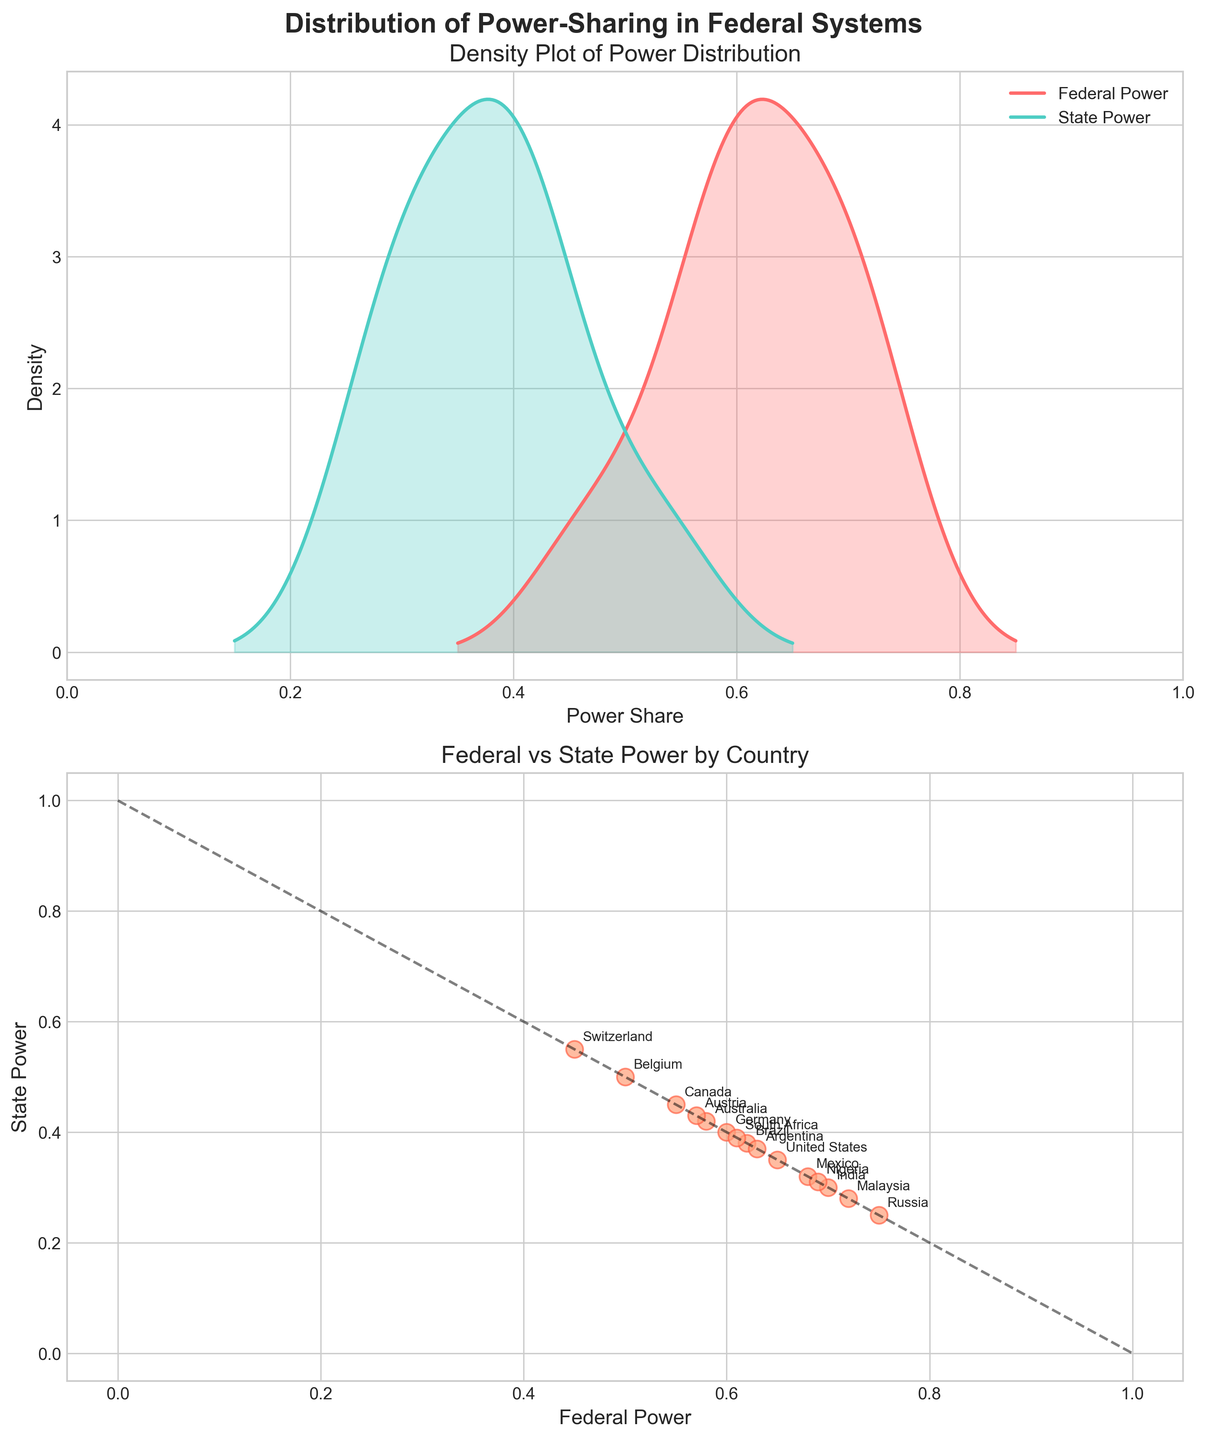What is the title of the figure? The title is written at the top of the figure in large, bold font. It reads "Distribution of Power-Sharing in Federal Systems".
Answer: Distribution of Power-Sharing in Federal Systems Which country has the highest Federal Power share? By looking at the scatter plot, the country with the highest Federal Power share is positioned farthest to the right on the x-axis. Russia is the farthest, indicating it has the highest Federal Power share.
Answer: Russia What are the minimum and maximum values for State Power depicted in the density plot? The density plot shows the distribution and range of State Power. The minimum and maximum values are identified at the endpoints of the x-axis where the density plot starts and ends. From the plot, the minimum State Power is around 0.25 and the maximum is around 0.55.
Answer: 0.25, 0.55 Which country has an equal share of Federal and State Power? The scatter plot includes labeled data points and there is a diagonal line representing equal Federal and State Power. The country that lies directly on this line has equal shares. Belgium is on the line, indicating it has equal Federal and State Power shares (0.50 each).
Answer: Belgium How does the shape of the Federal Power density plot compare to the State Power density plot? The shapes of the two density plots can be compared by looking at their respective curves in the density plot. The Federal Power plot is broader and has more variation, indicating more spread-out data, while the State Power plot is narrower and more peaked.
Answer: Federal Power plot is broader; State Power plot is narrower Are there more countries with a higher Federal Power share or a higher State Power share? By examining the scatter plot where most points lie relative to the diagonal line, we observe that more countries are above the line, indicating higher Federal Power compared to State Power.
Answer: Higher Federal Power share What is the range of Federal Power values? The range of Federal Power values is identified by observing the lowest and highest Federal Power values on the x-axis in both the scatter plot and density plot. It ranges from 0.45 (Switzerland) to 0.75 (Russia).
Answer: 0.45 to 0.75 Which two countries have the closest Federal and State Power share percentages? From the scatter plot, the two countries closest to the diagonal line besides Belgium (which has equal shares) are Germany (0.60, 0.40) and Brazil (0.62, 0.38).
Answer: Germany and Brazil Which country has the highest density in the Federal Power distribution? The peak of the Federal Power density plot indicates the point of highest density. The highest peak is around 0.65, where the density is maximum. The country closest to this value is the United States (0.65).
Answer: United States How is the relationship between Federal and State Power illustrated in the scatter plot? The scatter plot uses points and annotations to show the relationship; countries are plotted with Federal Power on the x-axis and State Power on the y-axis. A diagonal line illustrates when Federal and State Power are equal. Most points above the line indicate higher Federal Power.
Answer: Scatter plot with annotated points above diagonal line showing higher Federal Power 